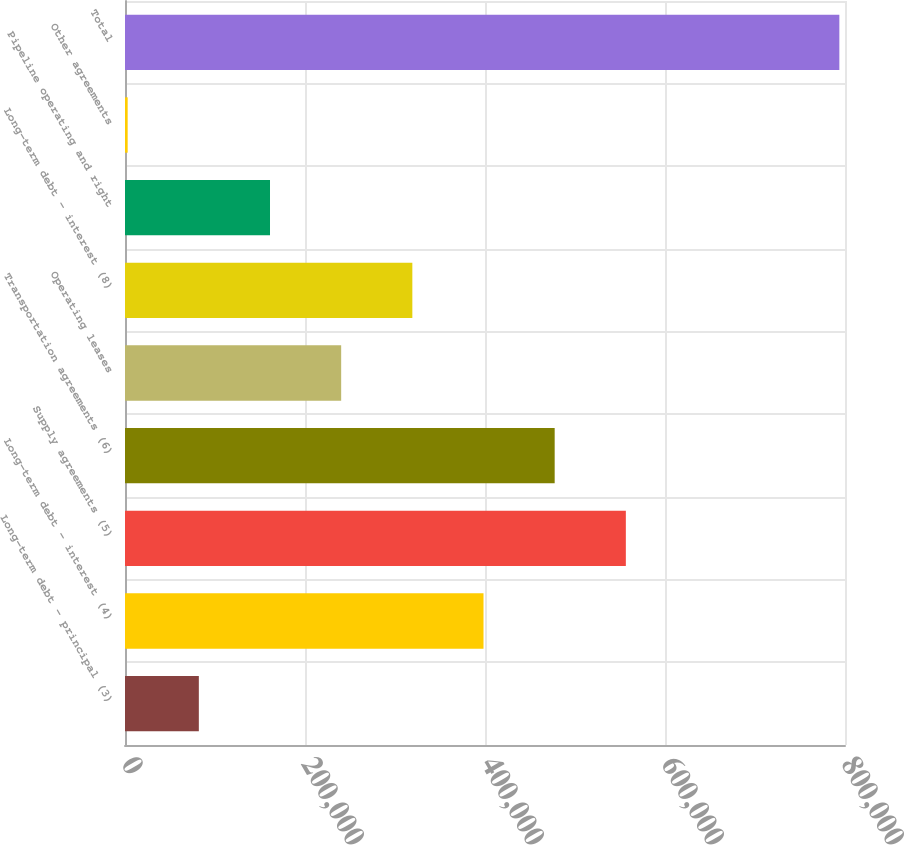<chart> <loc_0><loc_0><loc_500><loc_500><bar_chart><fcel>Long-term debt - principal (3)<fcel>Long-term debt - interest (4)<fcel>Supply agreements (5)<fcel>Transportation agreements (6)<fcel>Operating leases<fcel>Long-term debt - interest (8)<fcel>Pipeline operating and right<fcel>Other agreements<fcel>Total<nl><fcel>82042.6<fcel>398345<fcel>556496<fcel>477421<fcel>240194<fcel>319269<fcel>161118<fcel>2967<fcel>793723<nl></chart> 